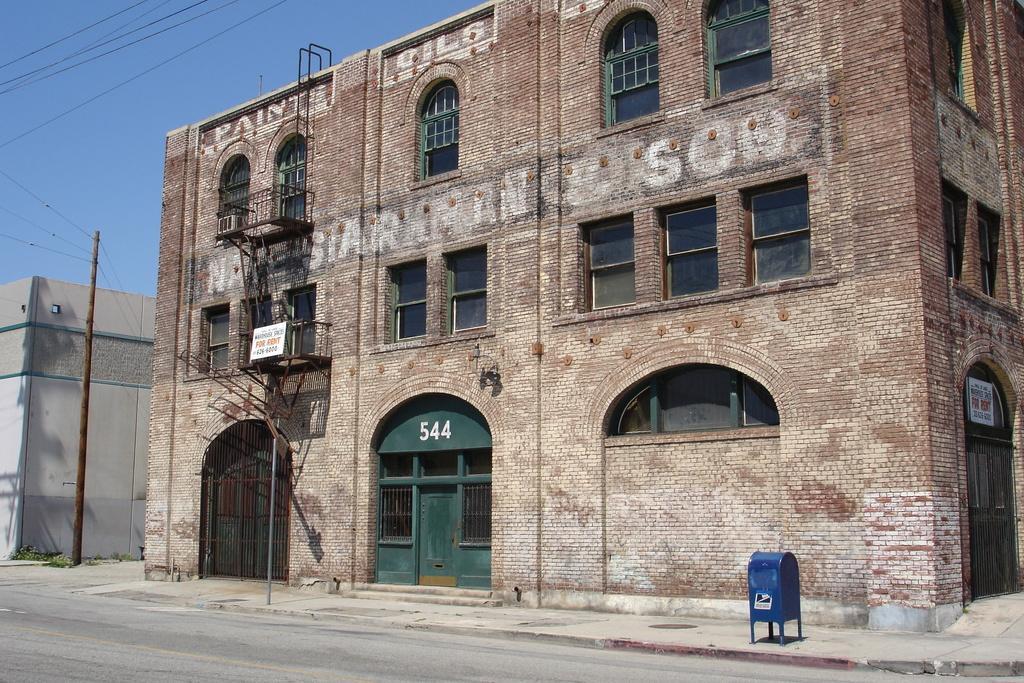In one or two sentences, can you explain what this image depicts? This is a road. There are buildings, windows, doors, boards, and poles. In the background there is sky. 